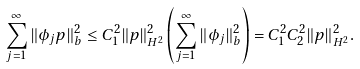Convert formula to latex. <formula><loc_0><loc_0><loc_500><loc_500>\sum _ { j = 1 } ^ { \infty } \| \phi _ { j } p \| _ { b } ^ { 2 } \leq C _ { 1 } ^ { 2 } \| p \| _ { H ^ { 2 } } ^ { 2 } \left ( \sum _ { j = 1 } ^ { \infty } \| \phi _ { j } \| _ { b } ^ { 2 } \right ) = C _ { 1 } ^ { 2 } C _ { 2 } ^ { 2 } \| p \| _ { H ^ { 2 } } ^ { 2 } .</formula> 